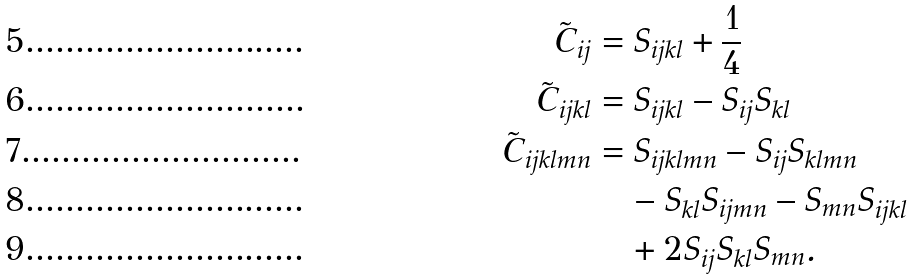<formula> <loc_0><loc_0><loc_500><loc_500>\tilde { C } _ { i j } & = S _ { i j k l } + \frac { 1 } { 4 } \\ \tilde { C } _ { i j k l } & = S _ { i j k l } - S _ { i j } S _ { k l } \\ \tilde { C } _ { i j k l m n } & = S _ { i j k l m n } - S _ { i j } S _ { k l m n } \\ & \quad - S _ { k l } S _ { i j m n } - S _ { m n } S _ { i j k l } \\ & \quad + 2 S _ { i j } S _ { k l } S _ { m n } .</formula> 